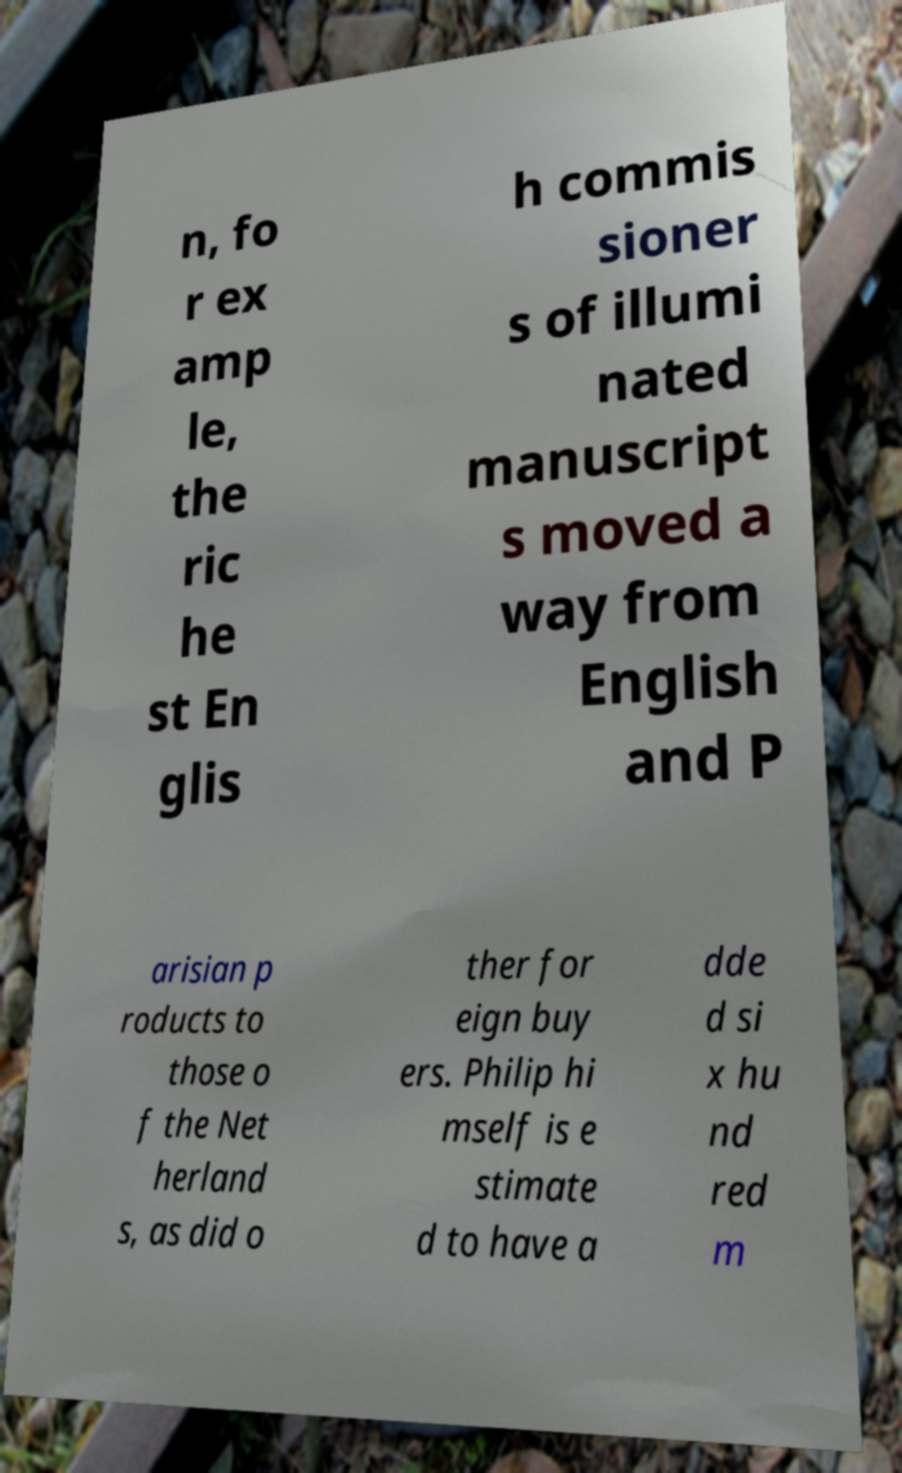Please identify and transcribe the text found in this image. n, fo r ex amp le, the ric he st En glis h commis sioner s of illumi nated manuscript s moved a way from English and P arisian p roducts to those o f the Net herland s, as did o ther for eign buy ers. Philip hi mself is e stimate d to have a dde d si x hu nd red m 